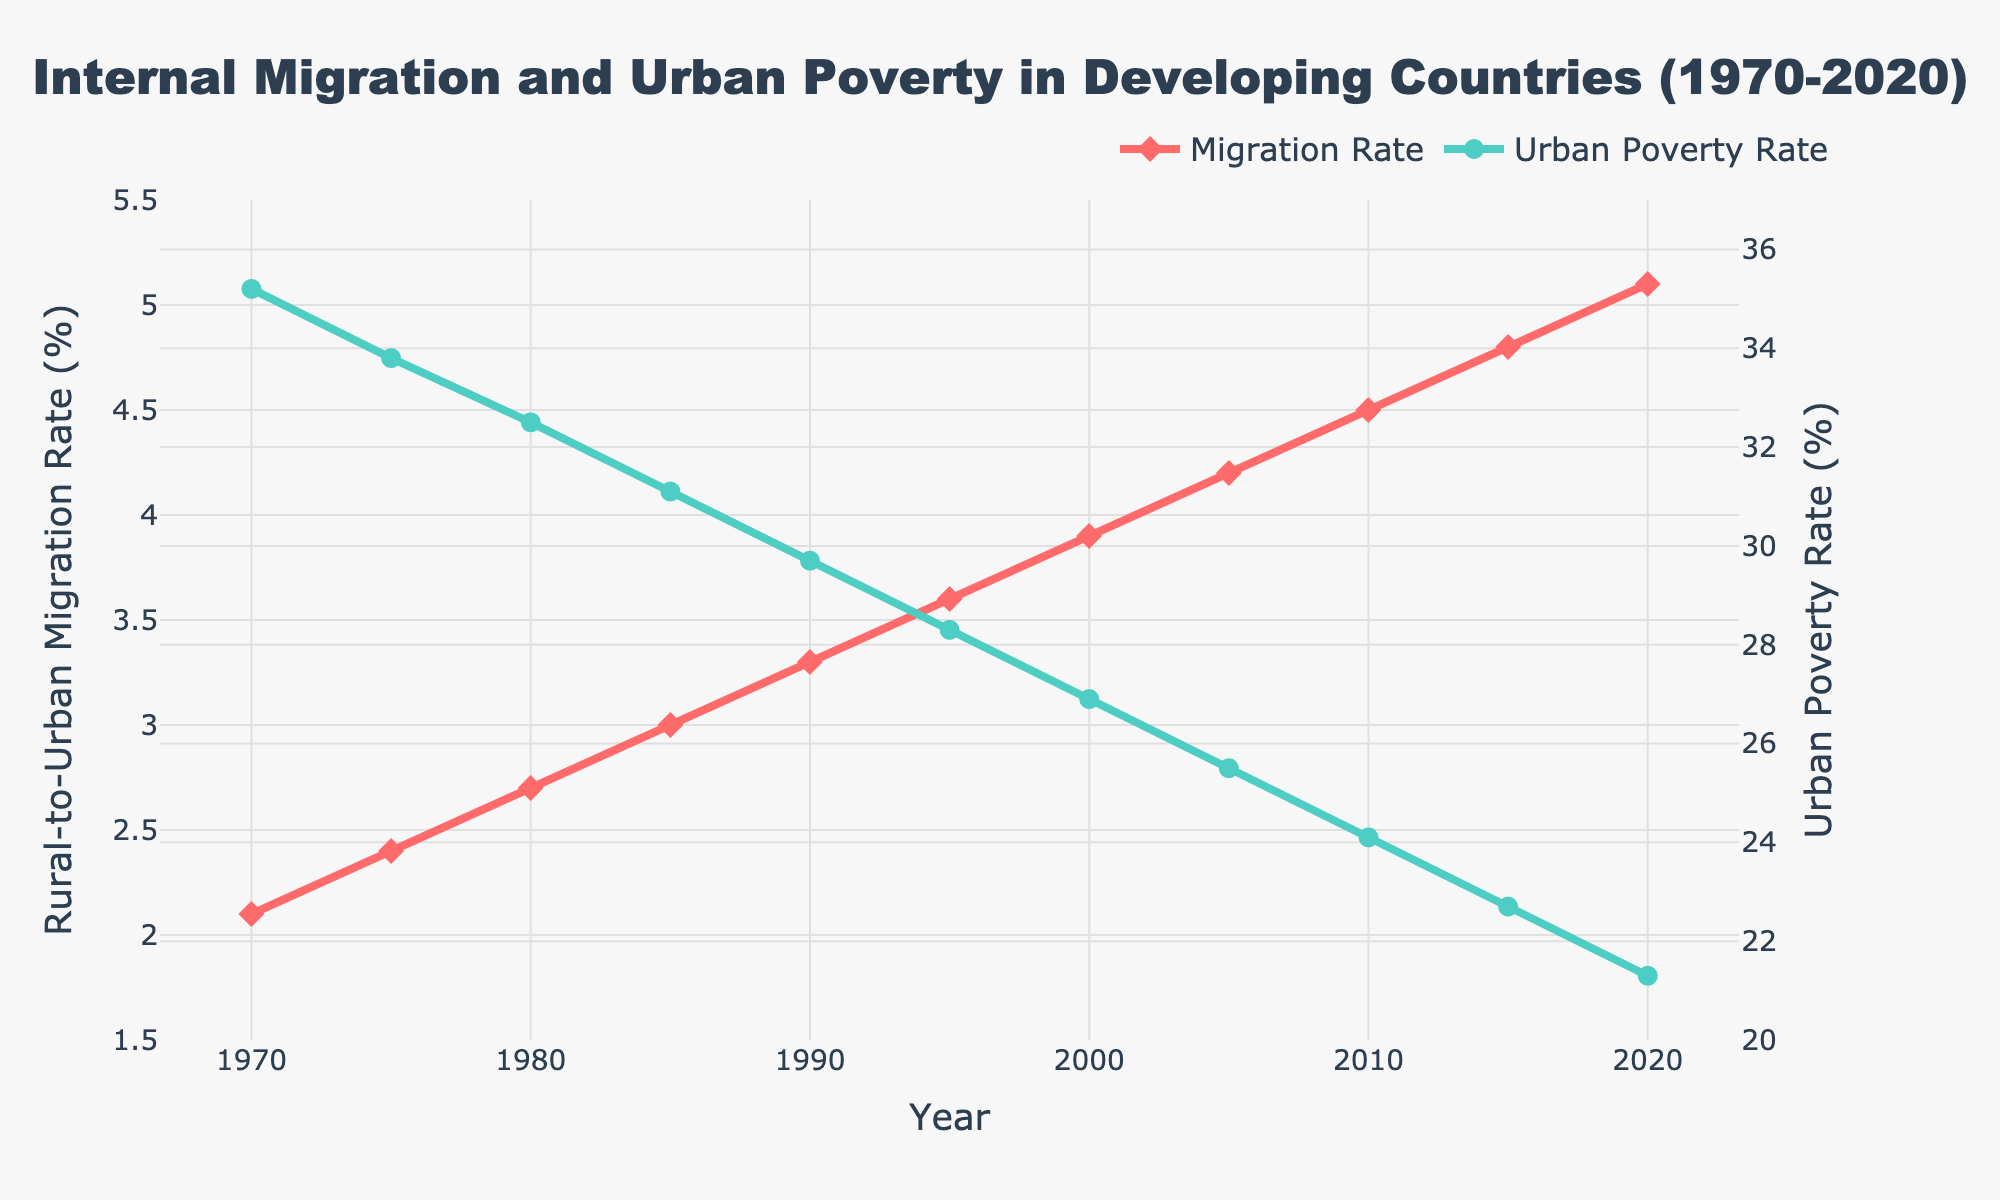What's the trend in the Rural-to-Urban Migration Rate from 1970 to 2020? Look at the red line representing the Rural-to-Urban Migration Rate. It starts at 2.1% in 1970 and steadily increases to 5.1% by 2020.
Answer: It increases How did the Urban Poverty Rate change from 1970 to 2020? Examine the green line representing the Urban Poverty Rate. It starts at 35.2% in 1970 and consistently decreases to 21.3% by 2020.
Answer: It decreases What is the difference in Urban Poverty Rate between 1970 and 2020? Subtract the Urban Poverty Rate in 2020 (21.3%) from the rate in 1970 (35.2%): 35.2% - 21.3% = 13.9%.
Answer: 13.9% Which year had the highest Rural-to-Urban Migration Rate? Locate the peak of the red line. The highest point on the line occurs at 2020 with a rate of 5.1%.
Answer: 2020 Compare the Urban Poverty Rate in 1980 and 2000. Which year had a lower rate? Find the values on the green line for 1980 (32.5%) and 2000 (26.9%). 2000 had a lower rate.
Answer: 2000 What is the average Rural-to-Urban Migration Rate from 1970 to 2020? Add all the Rural-to-Urban Migration Rates from the years 1970 (2.1%), 1975 (2.4%), 1980 (2.7%), 1985 (3.0%), 1990 (3.3%), 1995 (3.6%), 2000 (3.9%), 2005 (4.2%), 2010 (4.5%), 2015 (4.8%), and 2020 (5.1%) and divide by 11: (2.1 + 2.4 + 2.7 + 3.0 + 3.3 + 3.6 + 3.9 + 4.2 + 4.5 + 4.8 + 5.1) / 11 = 3.6%.
Answer: 3.6% In what year did the Urban Poverty Rate fall below 30% for the first time? Find the first point where the green line goes below 30%. This happens in 1990 with a rate of 29.7%.
Answer: 1990 What is the relationship between the increase in Rural-to-Urban Migration Rate and the decrease in Urban Poverty Rate? Observe the overall trends: as the Rural-to-Urban Migration Rate (red line) increases from 2.1% to 5.1%, the Urban Poverty Rate (green line) decreases from 35.2% to 21.3%. This suggests a negative correlation.
Answer: Negative correlation Between 1980 and 2000, how much did the Urban Poverty Rate decrease? Subtract the Urban Poverty Rate in 2000 (26.9%) from the rate in 1980 (32.5%): 32.5% - 26.9% = 5.6%.
Answer: 5.6% What is the visual characteristic of the data points for the Migration Rate? Look at the shapes and colors used in the chart. The data points for the Migration Rate are represented by red diamonds.
Answer: Red diamonds 